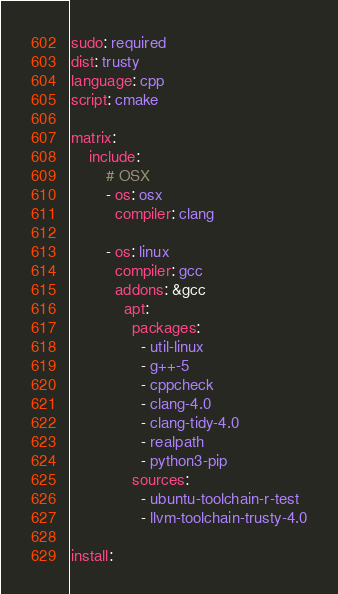Convert code to text. <code><loc_0><loc_0><loc_500><loc_500><_YAML_>sudo: required
dist: trusty
language: cpp
script: cmake

matrix:
    include:
        # OSX
        - os: osx
          compiler: clang

        - os: linux
          compiler: gcc
          addons: &gcc
            apt:
              packages:
                - util-linux
                - g++-5
                - cppcheck
                - clang-4.0
                - clang-tidy-4.0
                - realpath
                - python3-pip
              sources:
                - ubuntu-toolchain-r-test
                - llvm-toolchain-trusty-4.0

install:</code> 